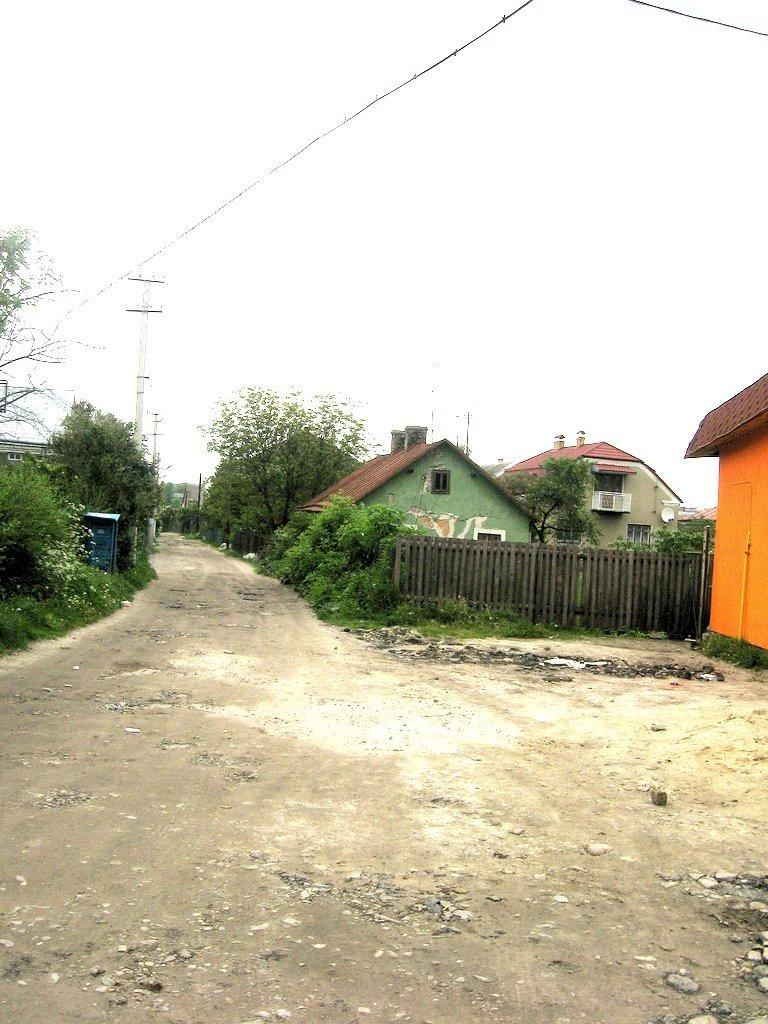What type of structures can be seen in the image? There are houses in the image. What type of barrier is present in the image? There is a wooden fence in the image. What type of vegetation can be seen in the image? There are plants and trees in the image. What type of vertical structures are present in the image? There are poles in the image. What can be seen in the background of the image? The sky is visible in the background of the image. How many hands are visible in the image? There are no hands visible in the image. What type of farm animals can be seen in the image? There are no farm animals, such as chickens, present in the image. 